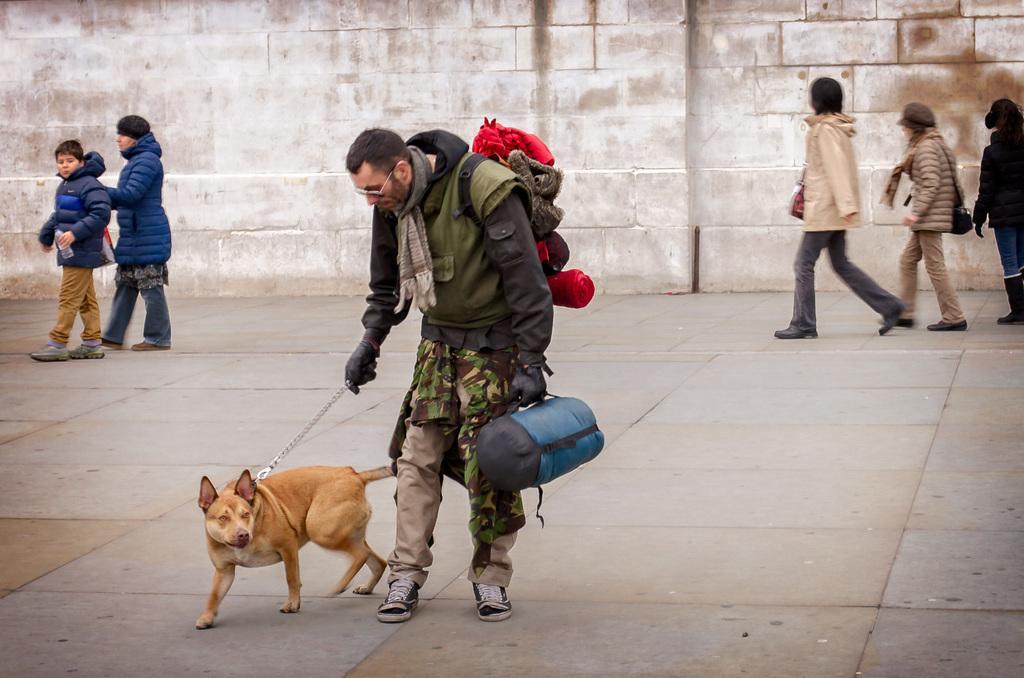Can you describe this image briefly? In the picture we can see a man holding a dog and a bag, In the background we can see some people are walking and there is a wall. 